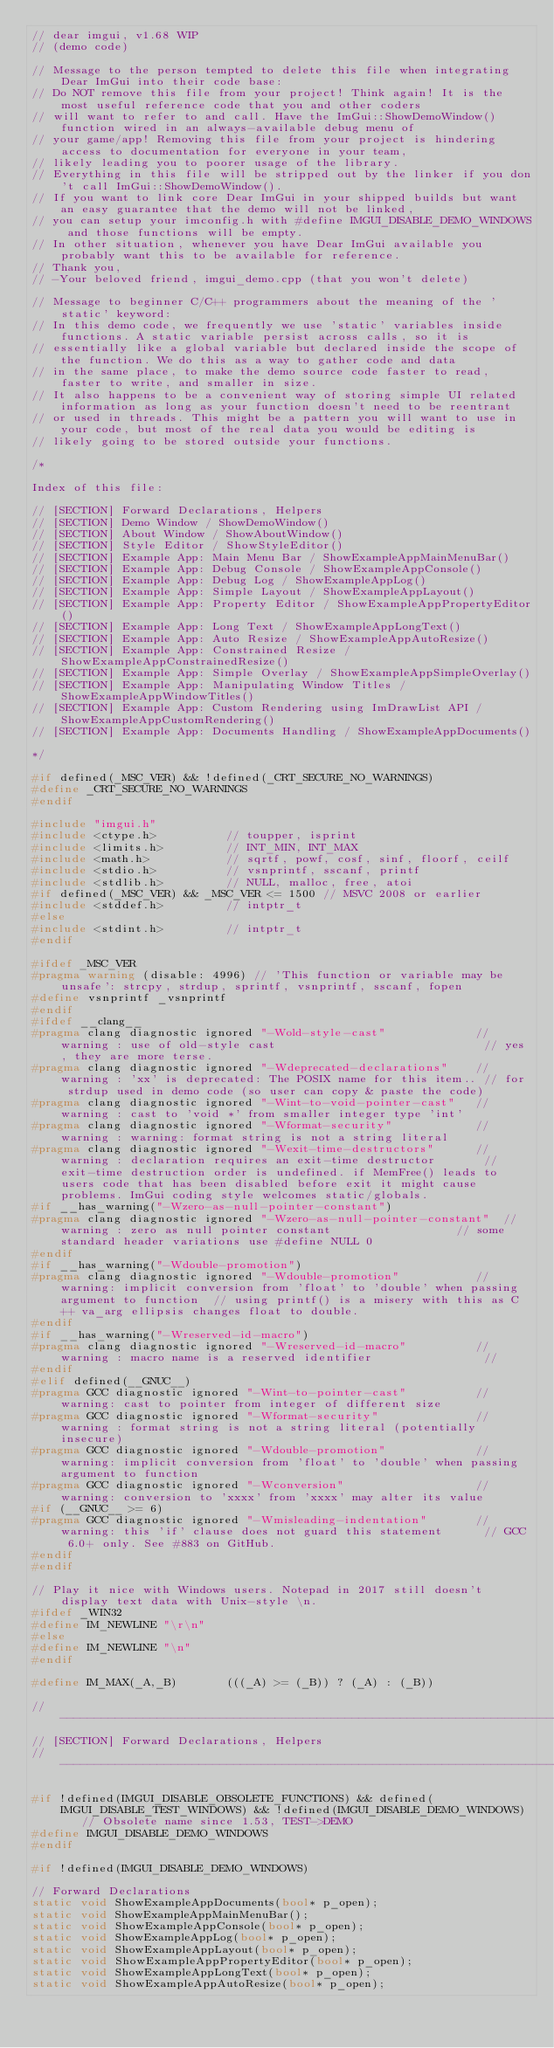Convert code to text. <code><loc_0><loc_0><loc_500><loc_500><_C++_>// dear imgui, v1.68 WIP
// (demo code)

// Message to the person tempted to delete this file when integrating Dear ImGui into their code base:
// Do NOT remove this file from your project! Think again! It is the most useful reference code that you and other coders
// will want to refer to and call. Have the ImGui::ShowDemoWindow() function wired in an always-available debug menu of
// your game/app! Removing this file from your project is hindering access to documentation for everyone in your team,
// likely leading you to poorer usage of the library.
// Everything in this file will be stripped out by the linker if you don't call ImGui::ShowDemoWindow().
// If you want to link core Dear ImGui in your shipped builds but want an easy guarantee that the demo will not be linked,
// you can setup your imconfig.h with #define IMGUI_DISABLE_DEMO_WINDOWS and those functions will be empty.
// In other situation, whenever you have Dear ImGui available you probably want this to be available for reference.
// Thank you,
// -Your beloved friend, imgui_demo.cpp (that you won't delete)

// Message to beginner C/C++ programmers about the meaning of the 'static' keyword:
// In this demo code, we frequently we use 'static' variables inside functions. A static variable persist across calls, so it is
// essentially like a global variable but declared inside the scope of the function. We do this as a way to gather code and data
// in the same place, to make the demo source code faster to read, faster to write, and smaller in size.
// It also happens to be a convenient way of storing simple UI related information as long as your function doesn't need to be reentrant
// or used in threads. This might be a pattern you will want to use in your code, but most of the real data you would be editing is
// likely going to be stored outside your functions.

/*

Index of this file:

// [SECTION] Forward Declarations, Helpers
// [SECTION] Demo Window / ShowDemoWindow()
// [SECTION] About Window / ShowAboutWindow()
// [SECTION] Style Editor / ShowStyleEditor()
// [SECTION] Example App: Main Menu Bar / ShowExampleAppMainMenuBar()
// [SECTION] Example App: Debug Console / ShowExampleAppConsole()
// [SECTION] Example App: Debug Log / ShowExampleAppLog()
// [SECTION] Example App: Simple Layout / ShowExampleAppLayout()
// [SECTION] Example App: Property Editor / ShowExampleAppPropertyEditor()
// [SECTION] Example App: Long Text / ShowExampleAppLongText()
// [SECTION] Example App: Auto Resize / ShowExampleAppAutoResize()
// [SECTION] Example App: Constrained Resize / ShowExampleAppConstrainedResize()
// [SECTION] Example App: Simple Overlay / ShowExampleAppSimpleOverlay()
// [SECTION] Example App: Manipulating Window Titles / ShowExampleAppWindowTitles()
// [SECTION] Example App: Custom Rendering using ImDrawList API / ShowExampleAppCustomRendering()
// [SECTION] Example App: Documents Handling / ShowExampleAppDocuments()

*/

#if defined(_MSC_VER) && !defined(_CRT_SECURE_NO_WARNINGS)
#define _CRT_SECURE_NO_WARNINGS
#endif

#include "imgui.h"
#include <ctype.h>          // toupper, isprint
#include <limits.h>         // INT_MIN, INT_MAX
#include <math.h>           // sqrtf, powf, cosf, sinf, floorf, ceilf
#include <stdio.h>          // vsnprintf, sscanf, printf
#include <stdlib.h>         // NULL, malloc, free, atoi
#if defined(_MSC_VER) && _MSC_VER <= 1500 // MSVC 2008 or earlier
#include <stddef.h>         // intptr_t
#else
#include <stdint.h>         // intptr_t
#endif

#ifdef _MSC_VER
#pragma warning (disable: 4996) // 'This function or variable may be unsafe': strcpy, strdup, sprintf, vsnprintf, sscanf, fopen
#define vsnprintf _vsnprintf
#endif
#ifdef __clang__
#pragma clang diagnostic ignored "-Wold-style-cast"             // warning : use of old-style cast                              // yes, they are more terse.
#pragma clang diagnostic ignored "-Wdeprecated-declarations"    // warning : 'xx' is deprecated: The POSIX name for this item.. // for strdup used in demo code (so user can copy & paste the code)
#pragma clang diagnostic ignored "-Wint-to-void-pointer-cast"   // warning : cast to 'void *' from smaller integer type 'int'
#pragma clang diagnostic ignored "-Wformat-security"            // warning : warning: format string is not a string literal
#pragma clang diagnostic ignored "-Wexit-time-destructors"      // warning : declaration requires an exit-time destructor       // exit-time destruction order is undefined. if MemFree() leads to users code that has been disabled before exit it might cause problems. ImGui coding style welcomes static/globals.
#if __has_warning("-Wzero-as-null-pointer-constant")
#pragma clang diagnostic ignored "-Wzero-as-null-pointer-constant"  // warning : zero as null pointer constant                  // some standard header variations use #define NULL 0
#endif
#if __has_warning("-Wdouble-promotion")
#pragma clang diagnostic ignored "-Wdouble-promotion"           // warning: implicit conversion from 'float' to 'double' when passing argument to function  // using printf() is a misery with this as C++ va_arg ellipsis changes float to double.
#endif
#if __has_warning("-Wreserved-id-macro")
#pragma clang diagnostic ignored "-Wreserved-id-macro"          // warning : macro name is a reserved identifier                //
#endif
#elif defined(__GNUC__)
#pragma GCC diagnostic ignored "-Wint-to-pointer-cast"          // warning: cast to pointer from integer of different size
#pragma GCC diagnostic ignored "-Wformat-security"              // warning : format string is not a string literal (potentially insecure)
#pragma GCC diagnostic ignored "-Wdouble-promotion"             // warning: implicit conversion from 'float' to 'double' when passing argument to function
#pragma GCC diagnostic ignored "-Wconversion"                   // warning: conversion to 'xxxx' from 'xxxx' may alter its value
#if (__GNUC__ >= 6)
#pragma GCC diagnostic ignored "-Wmisleading-indentation"       // warning: this 'if' clause does not guard this statement      // GCC 6.0+ only. See #883 on GitHub.
#endif
#endif

// Play it nice with Windows users. Notepad in 2017 still doesn't display text data with Unix-style \n.
#ifdef _WIN32
#define IM_NEWLINE "\r\n"
#else
#define IM_NEWLINE "\n"
#endif

#define IM_MAX(_A,_B)       (((_A) >= (_B)) ? (_A) : (_B))

//-----------------------------------------------------------------------------
// [SECTION] Forward Declarations, Helpers
//-----------------------------------------------------------------------------

#if !defined(IMGUI_DISABLE_OBSOLETE_FUNCTIONS) && defined(IMGUI_DISABLE_TEST_WINDOWS) && !defined(IMGUI_DISABLE_DEMO_WINDOWS)   // Obsolete name since 1.53, TEST->DEMO
#define IMGUI_DISABLE_DEMO_WINDOWS
#endif

#if !defined(IMGUI_DISABLE_DEMO_WINDOWS)

// Forward Declarations
static void ShowExampleAppDocuments(bool* p_open);
static void ShowExampleAppMainMenuBar();
static void ShowExampleAppConsole(bool* p_open);
static void ShowExampleAppLog(bool* p_open);
static void ShowExampleAppLayout(bool* p_open);
static void ShowExampleAppPropertyEditor(bool* p_open);
static void ShowExampleAppLongText(bool* p_open);
static void ShowExampleAppAutoResize(bool* p_open);</code> 